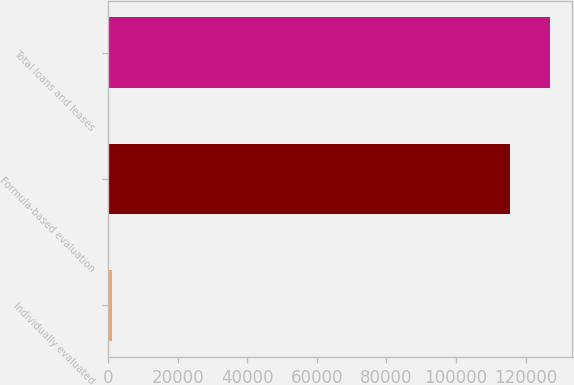Convert chart. <chart><loc_0><loc_0><loc_500><loc_500><bar_chart><fcel>Individually evaluated<fcel>Formula-based evaluation<fcel>Total loans and leases<nl><fcel>1114<fcel>115546<fcel>127101<nl></chart> 